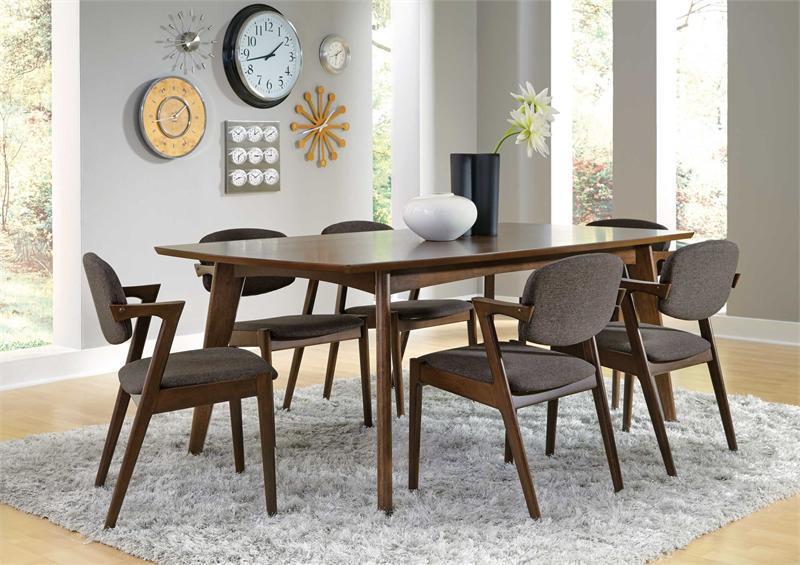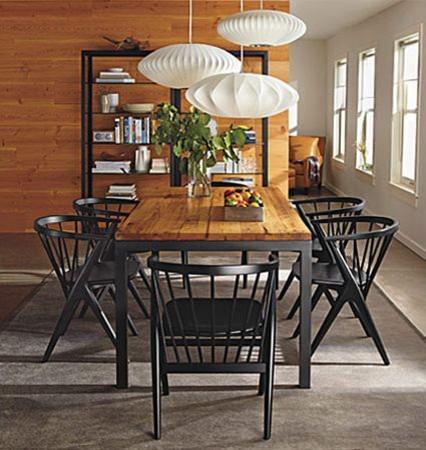The first image is the image on the left, the second image is the image on the right. For the images shown, is this caption "there are exactly two chairs in the image on the right" true? Answer yes or no. No. The first image is the image on the left, the second image is the image on the right. Evaluate the accuracy of this statement regarding the images: "At least one image shows a rectangular dining table with chairs on each side and each end.". Is it true? Answer yes or no. Yes. 